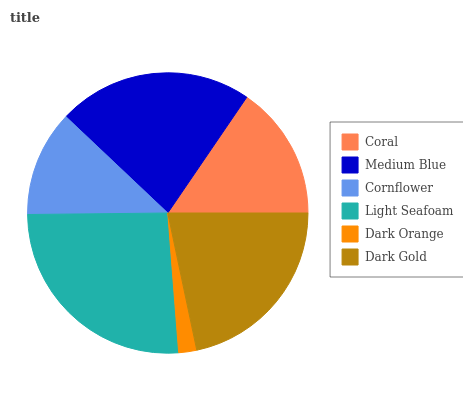Is Dark Orange the minimum?
Answer yes or no. Yes. Is Light Seafoam the maximum?
Answer yes or no. Yes. Is Medium Blue the minimum?
Answer yes or no. No. Is Medium Blue the maximum?
Answer yes or no. No. Is Medium Blue greater than Coral?
Answer yes or no. Yes. Is Coral less than Medium Blue?
Answer yes or no. Yes. Is Coral greater than Medium Blue?
Answer yes or no. No. Is Medium Blue less than Coral?
Answer yes or no. No. Is Dark Gold the high median?
Answer yes or no. Yes. Is Coral the low median?
Answer yes or no. Yes. Is Cornflower the high median?
Answer yes or no. No. Is Cornflower the low median?
Answer yes or no. No. 